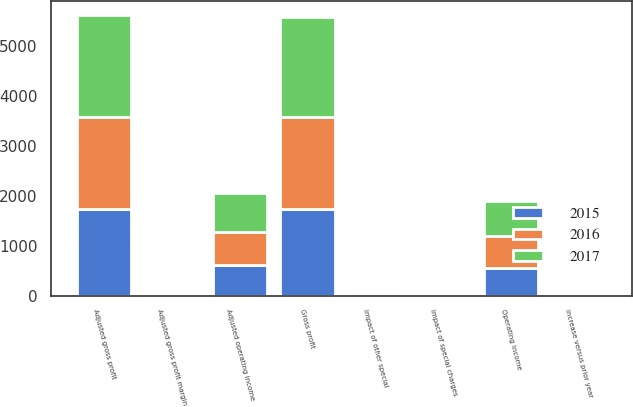<chart> <loc_0><loc_0><loc_500><loc_500><stacked_bar_chart><ecel><fcel>Gross profit<fcel>Impact of special charges<fcel>Adjusted gross profit<fcel>Adjusted gross profit margin<fcel>Operating income<fcel>Impact of other special<fcel>Adjusted operating income<fcel>increase versus prior year<nl><fcel>2017<fcel>2010.2<fcel>20.9<fcel>2031.1<fcel>42<fcel>702.4<fcel>22.2<fcel>786.3<fcel>19.7<nl><fcel>2016<fcel>1831.7<fcel>0.3<fcel>1832<fcel>41.5<fcel>641<fcel>15.7<fcel>657<fcel>7<nl><fcel>2015<fcel>1737.3<fcel>4<fcel>1741.3<fcel>40.5<fcel>548.4<fcel>61.5<fcel>613.9<fcel>0.9<nl></chart> 